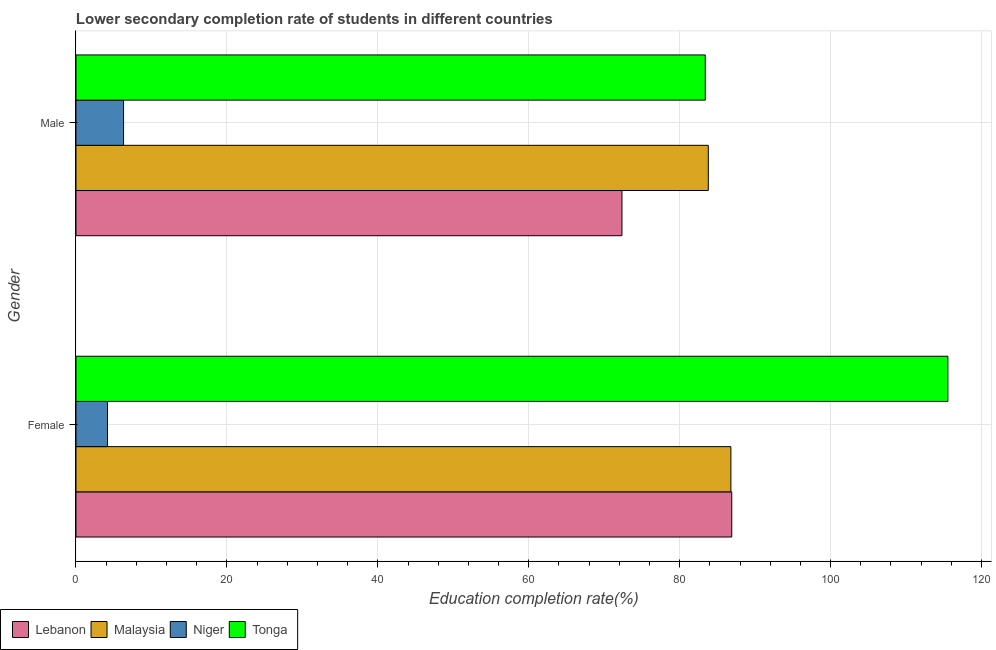How many different coloured bars are there?
Offer a terse response. 4. Are the number of bars on each tick of the Y-axis equal?
Ensure brevity in your answer.  Yes. What is the education completion rate of male students in Tonga?
Your answer should be very brief. 83.39. Across all countries, what is the maximum education completion rate of female students?
Make the answer very short. 115.54. Across all countries, what is the minimum education completion rate of male students?
Your response must be concise. 6.3. In which country was the education completion rate of male students maximum?
Your answer should be compact. Malaysia. In which country was the education completion rate of male students minimum?
Your answer should be very brief. Niger. What is the total education completion rate of male students in the graph?
Give a very brief answer. 245.84. What is the difference between the education completion rate of female students in Tonga and that in Malaysia?
Keep it short and to the point. 28.76. What is the difference between the education completion rate of male students in Tonga and the education completion rate of female students in Niger?
Make the answer very short. 79.22. What is the average education completion rate of male students per country?
Ensure brevity in your answer.  61.46. What is the difference between the education completion rate of female students and education completion rate of male students in Tonga?
Ensure brevity in your answer.  32.15. What is the ratio of the education completion rate of female students in Lebanon to that in Malaysia?
Make the answer very short. 1. Is the education completion rate of male students in Lebanon less than that in Malaysia?
Your answer should be compact. Yes. What does the 2nd bar from the top in Male represents?
Keep it short and to the point. Niger. What does the 2nd bar from the bottom in Male represents?
Give a very brief answer. Malaysia. How many bars are there?
Provide a succinct answer. 8. Are all the bars in the graph horizontal?
Keep it short and to the point. Yes. How many countries are there in the graph?
Keep it short and to the point. 4. What is the difference between two consecutive major ticks on the X-axis?
Ensure brevity in your answer.  20. Are the values on the major ticks of X-axis written in scientific E-notation?
Keep it short and to the point. No. What is the title of the graph?
Provide a succinct answer. Lower secondary completion rate of students in different countries. What is the label or title of the X-axis?
Your answer should be compact. Education completion rate(%). What is the Education completion rate(%) of Lebanon in Female?
Provide a succinct answer. 86.9. What is the Education completion rate(%) of Malaysia in Female?
Provide a short and direct response. 86.79. What is the Education completion rate(%) of Niger in Female?
Provide a short and direct response. 4.17. What is the Education completion rate(%) of Tonga in Female?
Your answer should be compact. 115.54. What is the Education completion rate(%) of Lebanon in Male?
Offer a terse response. 72.35. What is the Education completion rate(%) of Malaysia in Male?
Keep it short and to the point. 83.79. What is the Education completion rate(%) in Niger in Male?
Offer a terse response. 6.3. What is the Education completion rate(%) of Tonga in Male?
Provide a succinct answer. 83.39. Across all Gender, what is the maximum Education completion rate(%) of Lebanon?
Your answer should be compact. 86.9. Across all Gender, what is the maximum Education completion rate(%) of Malaysia?
Provide a succinct answer. 86.79. Across all Gender, what is the maximum Education completion rate(%) in Niger?
Provide a short and direct response. 6.3. Across all Gender, what is the maximum Education completion rate(%) of Tonga?
Give a very brief answer. 115.54. Across all Gender, what is the minimum Education completion rate(%) of Lebanon?
Give a very brief answer. 72.35. Across all Gender, what is the minimum Education completion rate(%) of Malaysia?
Your answer should be very brief. 83.79. Across all Gender, what is the minimum Education completion rate(%) of Niger?
Provide a short and direct response. 4.17. Across all Gender, what is the minimum Education completion rate(%) of Tonga?
Provide a succinct answer. 83.39. What is the total Education completion rate(%) of Lebanon in the graph?
Provide a succinct answer. 159.25. What is the total Education completion rate(%) of Malaysia in the graph?
Give a very brief answer. 170.58. What is the total Education completion rate(%) in Niger in the graph?
Offer a very short reply. 10.48. What is the total Education completion rate(%) in Tonga in the graph?
Provide a short and direct response. 198.94. What is the difference between the Education completion rate(%) of Lebanon in Female and that in Male?
Your answer should be compact. 14.55. What is the difference between the Education completion rate(%) in Malaysia in Female and that in Male?
Your answer should be compact. 2.99. What is the difference between the Education completion rate(%) of Niger in Female and that in Male?
Offer a terse response. -2.13. What is the difference between the Education completion rate(%) of Tonga in Female and that in Male?
Keep it short and to the point. 32.15. What is the difference between the Education completion rate(%) of Lebanon in Female and the Education completion rate(%) of Malaysia in Male?
Offer a terse response. 3.11. What is the difference between the Education completion rate(%) in Lebanon in Female and the Education completion rate(%) in Niger in Male?
Give a very brief answer. 80.6. What is the difference between the Education completion rate(%) in Lebanon in Female and the Education completion rate(%) in Tonga in Male?
Give a very brief answer. 3.51. What is the difference between the Education completion rate(%) of Malaysia in Female and the Education completion rate(%) of Niger in Male?
Offer a very short reply. 80.48. What is the difference between the Education completion rate(%) of Malaysia in Female and the Education completion rate(%) of Tonga in Male?
Your answer should be compact. 3.4. What is the difference between the Education completion rate(%) in Niger in Female and the Education completion rate(%) in Tonga in Male?
Your answer should be very brief. -79.22. What is the average Education completion rate(%) in Lebanon per Gender?
Ensure brevity in your answer.  79.63. What is the average Education completion rate(%) of Malaysia per Gender?
Ensure brevity in your answer.  85.29. What is the average Education completion rate(%) in Niger per Gender?
Keep it short and to the point. 5.24. What is the average Education completion rate(%) in Tonga per Gender?
Provide a succinct answer. 99.47. What is the difference between the Education completion rate(%) of Lebanon and Education completion rate(%) of Malaysia in Female?
Your response must be concise. 0.11. What is the difference between the Education completion rate(%) in Lebanon and Education completion rate(%) in Niger in Female?
Offer a very short reply. 82.73. What is the difference between the Education completion rate(%) of Lebanon and Education completion rate(%) of Tonga in Female?
Your answer should be very brief. -28.64. What is the difference between the Education completion rate(%) in Malaysia and Education completion rate(%) in Niger in Female?
Provide a short and direct response. 82.61. What is the difference between the Education completion rate(%) in Malaysia and Education completion rate(%) in Tonga in Female?
Your answer should be very brief. -28.76. What is the difference between the Education completion rate(%) in Niger and Education completion rate(%) in Tonga in Female?
Keep it short and to the point. -111.37. What is the difference between the Education completion rate(%) of Lebanon and Education completion rate(%) of Malaysia in Male?
Provide a short and direct response. -11.44. What is the difference between the Education completion rate(%) in Lebanon and Education completion rate(%) in Niger in Male?
Ensure brevity in your answer.  66.05. What is the difference between the Education completion rate(%) in Lebanon and Education completion rate(%) in Tonga in Male?
Ensure brevity in your answer.  -11.04. What is the difference between the Education completion rate(%) in Malaysia and Education completion rate(%) in Niger in Male?
Ensure brevity in your answer.  77.49. What is the difference between the Education completion rate(%) in Malaysia and Education completion rate(%) in Tonga in Male?
Make the answer very short. 0.4. What is the difference between the Education completion rate(%) in Niger and Education completion rate(%) in Tonga in Male?
Keep it short and to the point. -77.09. What is the ratio of the Education completion rate(%) of Lebanon in Female to that in Male?
Offer a very short reply. 1.2. What is the ratio of the Education completion rate(%) of Malaysia in Female to that in Male?
Make the answer very short. 1.04. What is the ratio of the Education completion rate(%) of Niger in Female to that in Male?
Ensure brevity in your answer.  0.66. What is the ratio of the Education completion rate(%) of Tonga in Female to that in Male?
Ensure brevity in your answer.  1.39. What is the difference between the highest and the second highest Education completion rate(%) in Lebanon?
Make the answer very short. 14.55. What is the difference between the highest and the second highest Education completion rate(%) of Malaysia?
Ensure brevity in your answer.  2.99. What is the difference between the highest and the second highest Education completion rate(%) in Niger?
Offer a terse response. 2.13. What is the difference between the highest and the second highest Education completion rate(%) in Tonga?
Offer a terse response. 32.15. What is the difference between the highest and the lowest Education completion rate(%) in Lebanon?
Offer a terse response. 14.55. What is the difference between the highest and the lowest Education completion rate(%) of Malaysia?
Give a very brief answer. 2.99. What is the difference between the highest and the lowest Education completion rate(%) in Niger?
Your answer should be compact. 2.13. What is the difference between the highest and the lowest Education completion rate(%) of Tonga?
Your response must be concise. 32.15. 